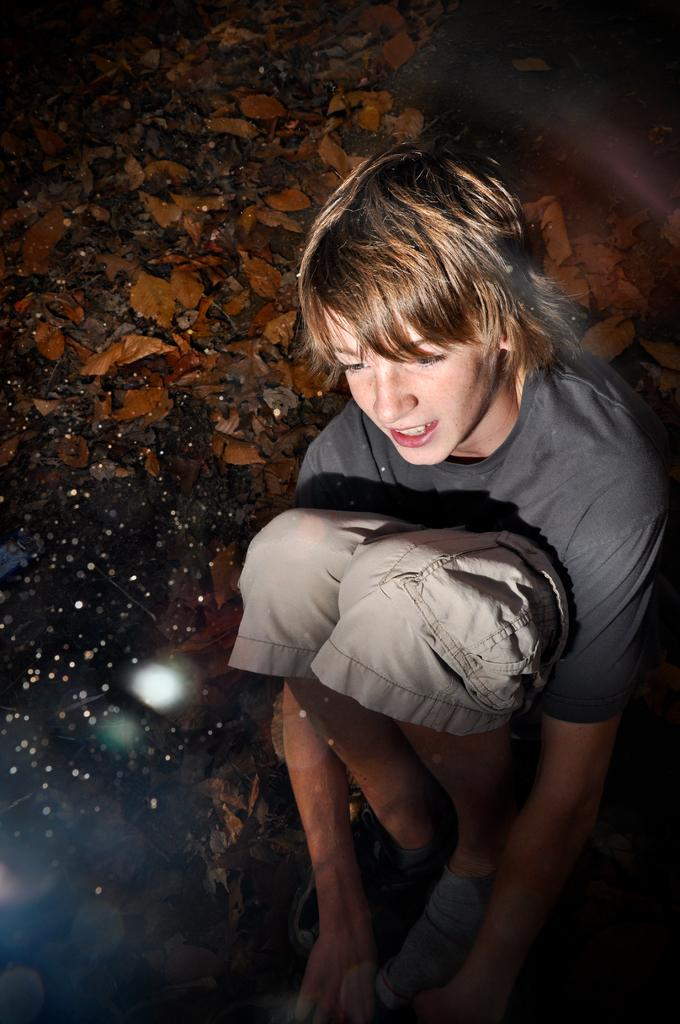Who is present in the image? There is a boy in the image. What is the boy doing in the image? The boy is sitting on the land. What can be seen on the land in the image? There are leaves on the land. What type of oven can be seen in the image? There is no oven present in the image. What role does the cast play in the image? There is no cast present in the image. 